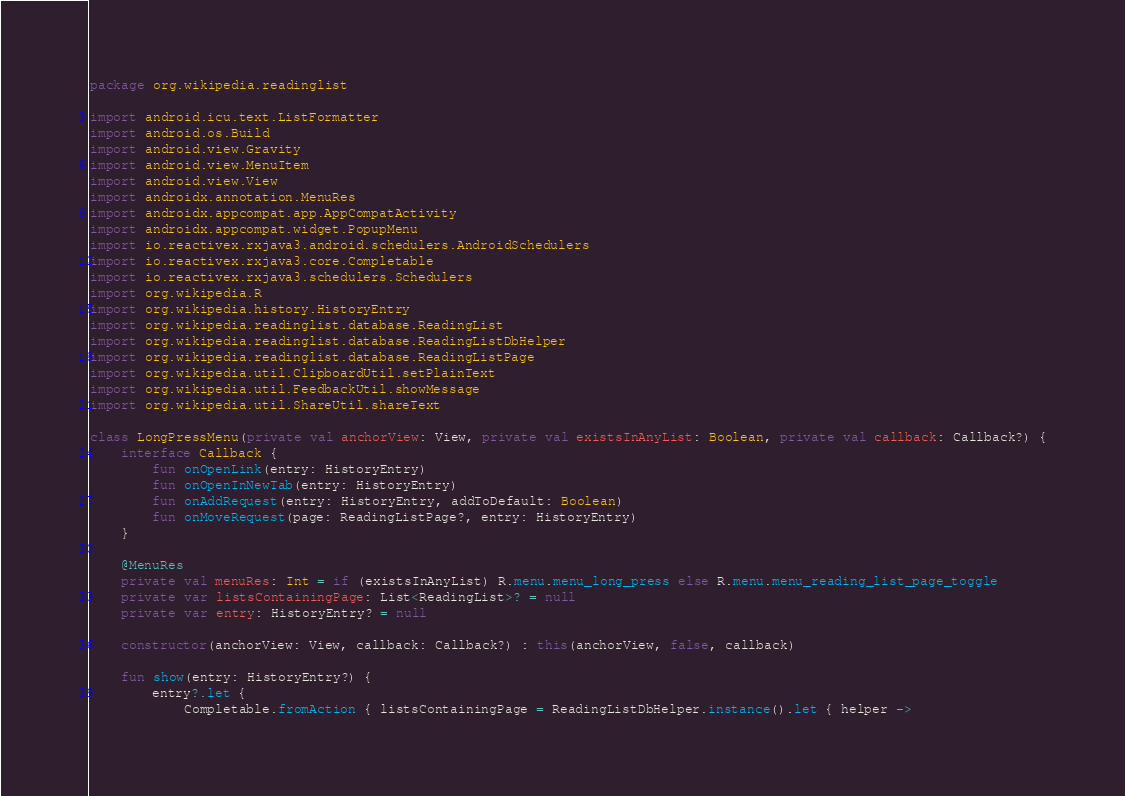Convert code to text. <code><loc_0><loc_0><loc_500><loc_500><_Kotlin_>package org.wikipedia.readinglist

import android.icu.text.ListFormatter
import android.os.Build
import android.view.Gravity
import android.view.MenuItem
import android.view.View
import androidx.annotation.MenuRes
import androidx.appcompat.app.AppCompatActivity
import androidx.appcompat.widget.PopupMenu
import io.reactivex.rxjava3.android.schedulers.AndroidSchedulers
import io.reactivex.rxjava3.core.Completable
import io.reactivex.rxjava3.schedulers.Schedulers
import org.wikipedia.R
import org.wikipedia.history.HistoryEntry
import org.wikipedia.readinglist.database.ReadingList
import org.wikipedia.readinglist.database.ReadingListDbHelper
import org.wikipedia.readinglist.database.ReadingListPage
import org.wikipedia.util.ClipboardUtil.setPlainText
import org.wikipedia.util.FeedbackUtil.showMessage
import org.wikipedia.util.ShareUtil.shareText

class LongPressMenu(private val anchorView: View, private val existsInAnyList: Boolean, private val callback: Callback?) {
    interface Callback {
        fun onOpenLink(entry: HistoryEntry)
        fun onOpenInNewTab(entry: HistoryEntry)
        fun onAddRequest(entry: HistoryEntry, addToDefault: Boolean)
        fun onMoveRequest(page: ReadingListPage?, entry: HistoryEntry)
    }

    @MenuRes
    private val menuRes: Int = if (existsInAnyList) R.menu.menu_long_press else R.menu.menu_reading_list_page_toggle
    private var listsContainingPage: List<ReadingList>? = null
    private var entry: HistoryEntry? = null

    constructor(anchorView: View, callback: Callback?) : this(anchorView, false, callback)

    fun show(entry: HistoryEntry?) {
        entry?.let {
            Completable.fromAction { listsContainingPage = ReadingListDbHelper.instance().let { helper -></code> 